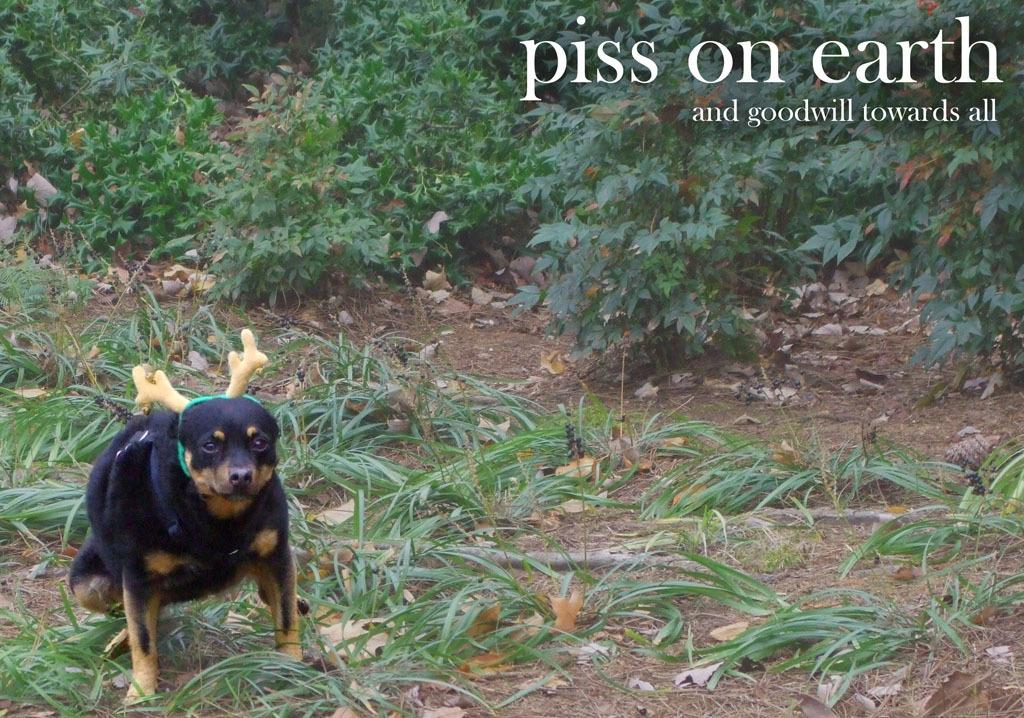What type of living organism can be seen in the image? There is an animal in the image. What is visible beneath the animal's feet? The ground is visible in the image, and there is grass on the ground. What other types of vegetation can be seen in the image? There are plants in the image, and dried leaves are present. Is there any text visible in the image? Yes, there is some text in the top right corner of the image. How many chairs are visible in the image? There are no chairs present in the image. What type of stick is being used by the animal in the image? There is no stick present in the image, and the animal is not using any object. 